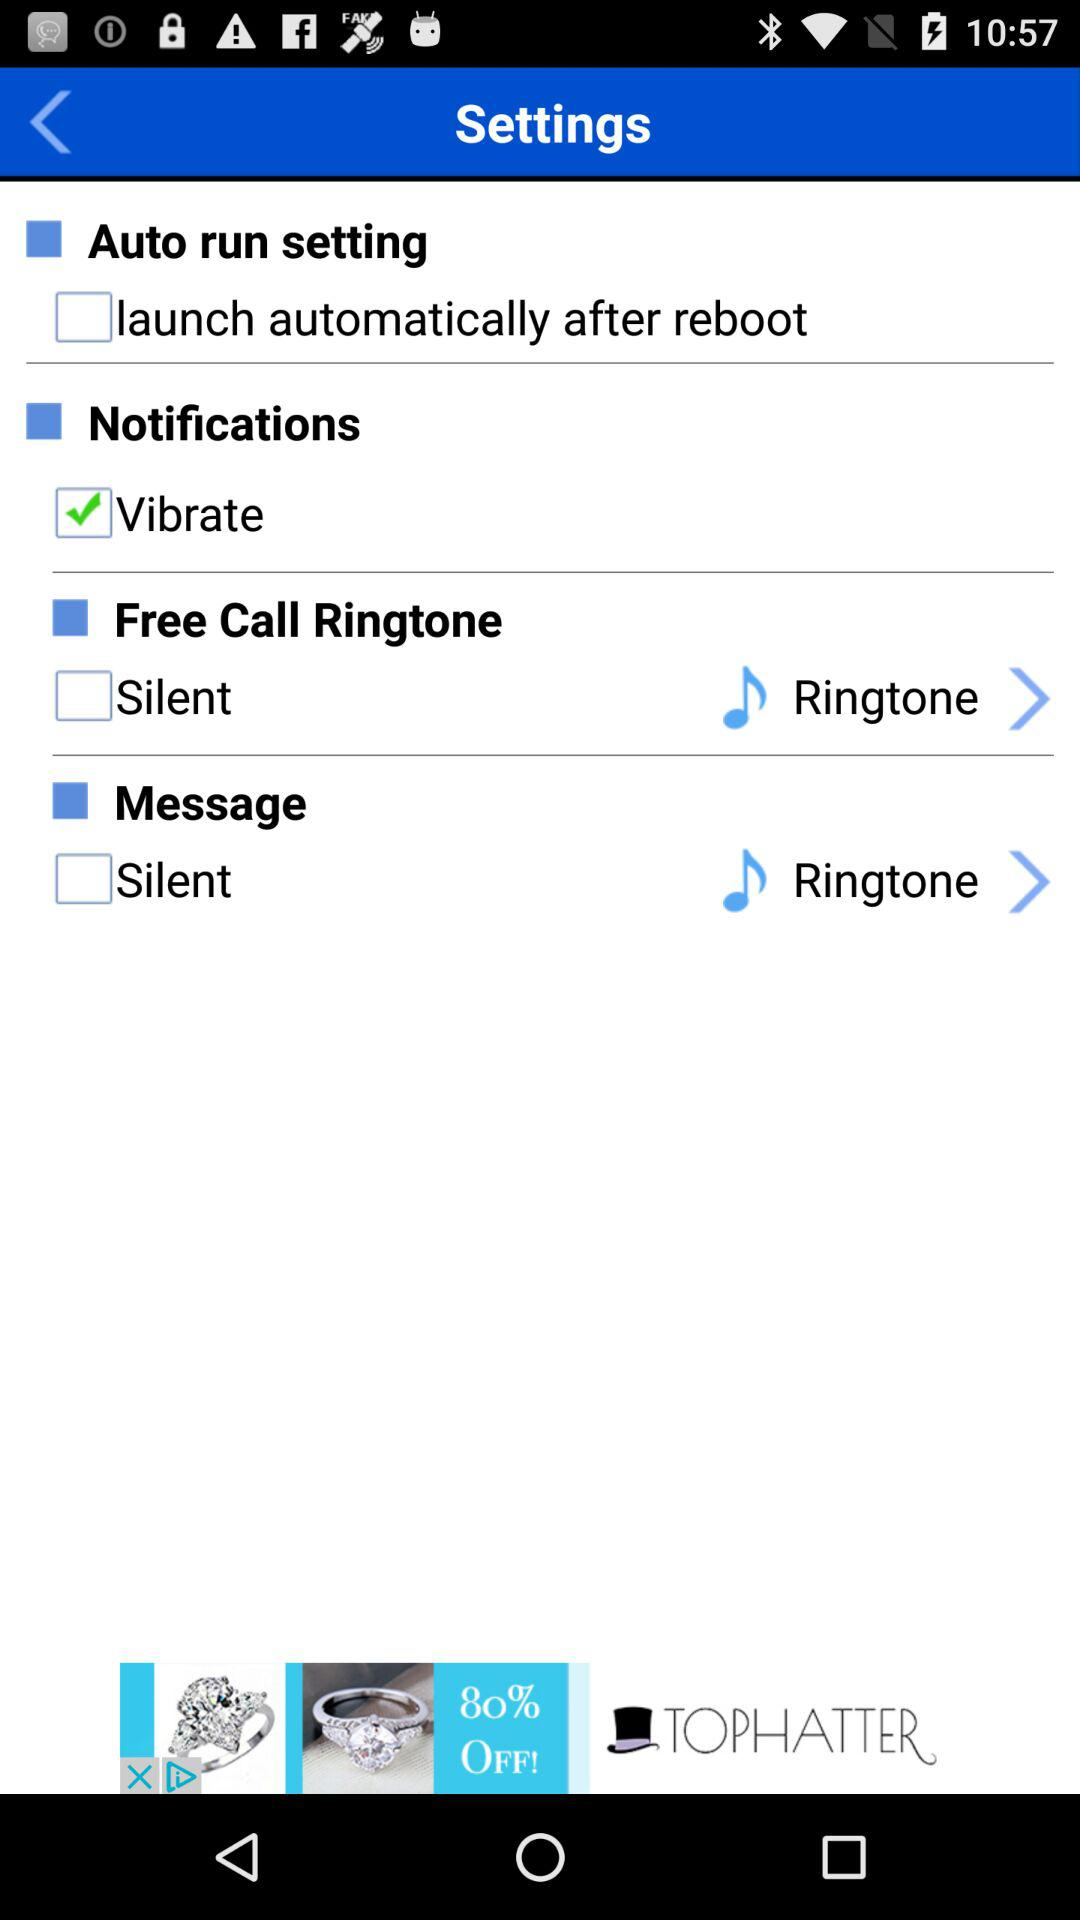What is the status of the message? The status of the message is off. 